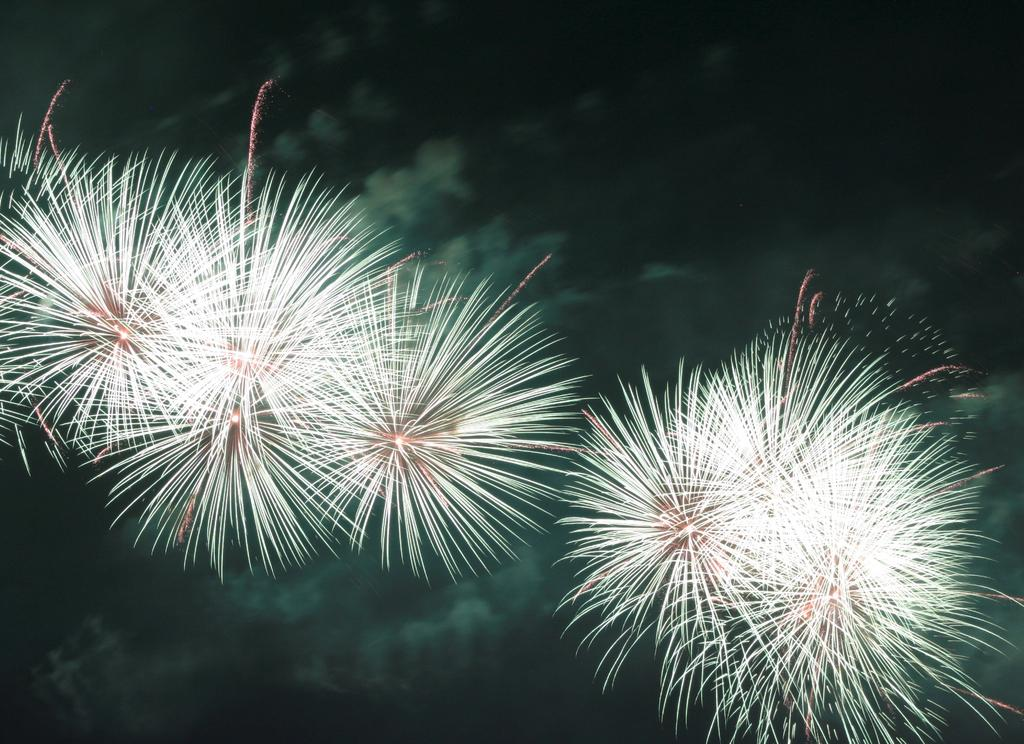What is happening with the crackers in the image? The crackers are lighting up into the air in the image. What colors of lights can be seen on the crackers? White and red color lights are visible in the image. What is the color of the sky in the background of the image? The sky in the background of the image is dark. How can you use the crackers to help someone in the image? The image does not depict a situation where the crackers can be used to help someone; they are simply lighting up into the air. 